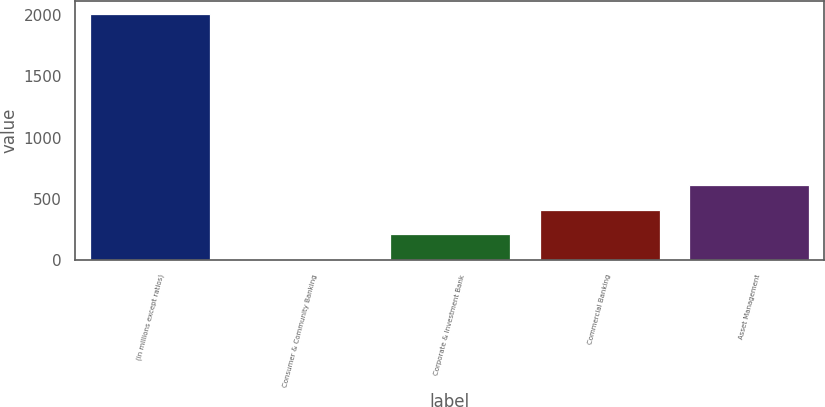Convert chart to OTSL. <chart><loc_0><loc_0><loc_500><loc_500><bar_chart><fcel>(in millions except ratios)<fcel>Consumer & Community Banking<fcel>Corporate & Investment Bank<fcel>Commercial Banking<fcel>Asset Management<nl><fcel>2010<fcel>11<fcel>210.9<fcel>410.8<fcel>610.7<nl></chart> 